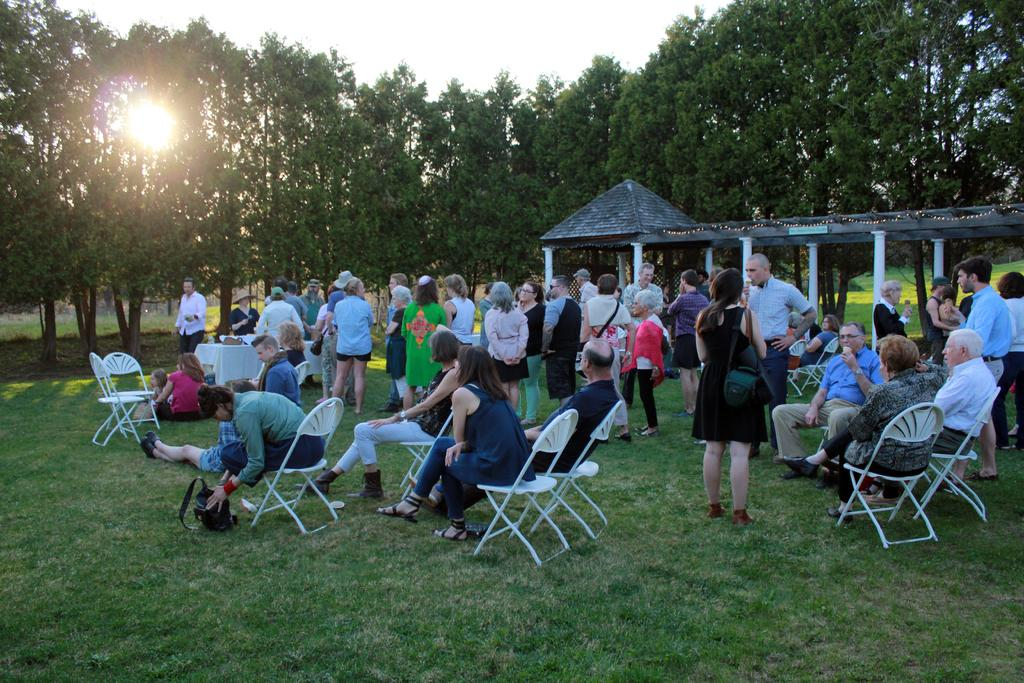What are the people in the image doing? There is a group of people sitting on chairs in the image, and there are people standing as well. What can be seen in the backdrop of the image? There are trees and the sky visible in the backdrop of the image. Is there any indication of the time of day in the image? Yes, the sun is observable in the backdrop of the image, suggesting it is daytime. Can you see any ice on the tongues of the people in the image? There is no ice or tongues visible in the image; it only shows people sitting and standing with trees and the sky in the backdrop. 